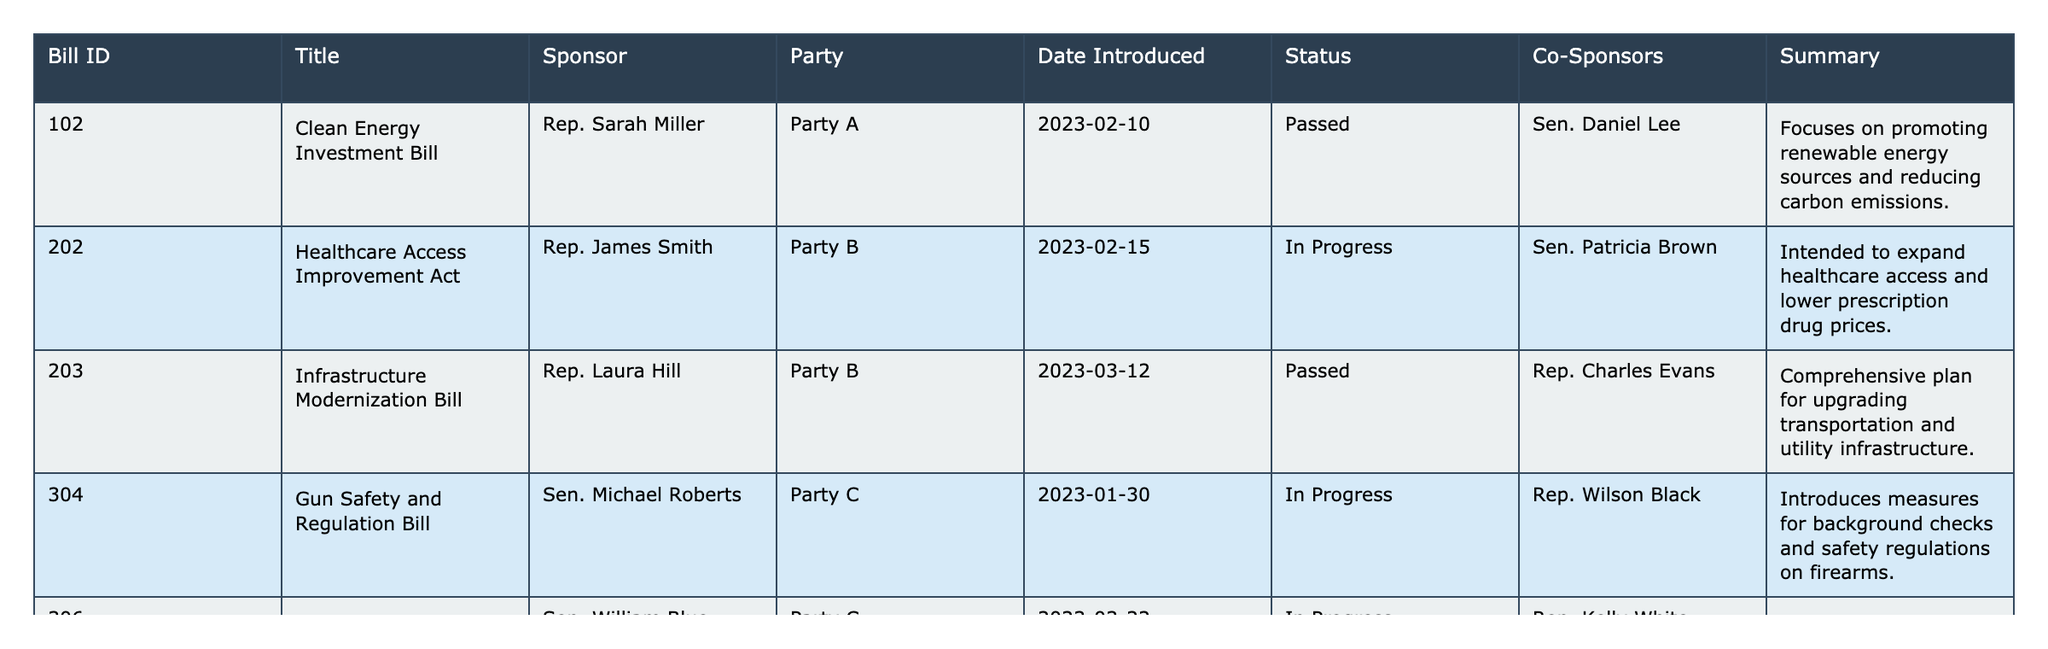What is the title of the bill sponsored by Rep. Sarah Miller? The table lists all bills accompanied by their respective sponsors. By looking for the row with "Rep. Sarah Miller" in the Sponsor column, the title is found to be "Clean Energy Investment Bill."
Answer: Clean Energy Investment Bill How many bills were sponsored by Party B? To find the number of bills sponsored by Party B, we count the rows where the Party column is "Party B." There are two entries (Healthcare Access Improvement Act and Infrastructure Modernization Bill).
Answer: 2 What is the status of the Economic Growth Strategies Act? In the table, the status of the bill is found by looking for "Economic Growth Strategies Act" and checking the Status column. It shows "Defeated."
Answer: Defeated Did any bills sponsored by Party D achieve "Passed" status? We review the rows in the table, checking the Status column for bills sponsored by Party D. The Social Justice and Equity Bill is the only one marked as "Passed."
Answer: Yes Which bill was introduced last according to the "Date Introduced"? To determine which bill was introduced last, we need to compare the dates in the Date Introduced column. The latest date is for the Digital Privacy Protection Act (2023-03-22).
Answer: Digital Privacy Protection Act How many total Co-Sponsors are listed for all bills in the table? The Co-Sponsors column must be inspected for each bill. There are three unique co-sponsors: Sen. Daniel Lee, Sen. Patricia Brown, and Rep. Charles Evans. Counting the unique entries gives a total of three.
Answer: 3 What is the summary of the Gun Safety and Regulation Bill? To answer this, we locate the row corresponding to "Gun Safety and Regulation Bill" and read the Summary column, which describes measures for background checks and regulations.
Answer: Introduces measures for background checks and safety regulations on firearms How many bills currently have "In Progress" status? We go through the table and count the entries in the Status column that are marked as "In Progress." There are three such bills: Healthcare Access Improvement Act, Gun Safety and Regulation Bill, and Digital Privacy Protection Act.
Answer: 3 What is the difference in the number of "Passed" bills between Party A and Party D? We identify the bills for Party A (1 Passed) and Party D (1 Passed). The difference is calculated as follows: 1 (Party A) - 1 (Party D) = 0.
Answer: 0 Are there any bills sponsored by Party C that are currently "Passed"? We look for entries under Party C in the Party column and check their respective Status. Both bills (Gun Safety and Regulation Bill and Digital Privacy Protection Act) are still "In Progress," indicating none are "Passed."
Answer: No 